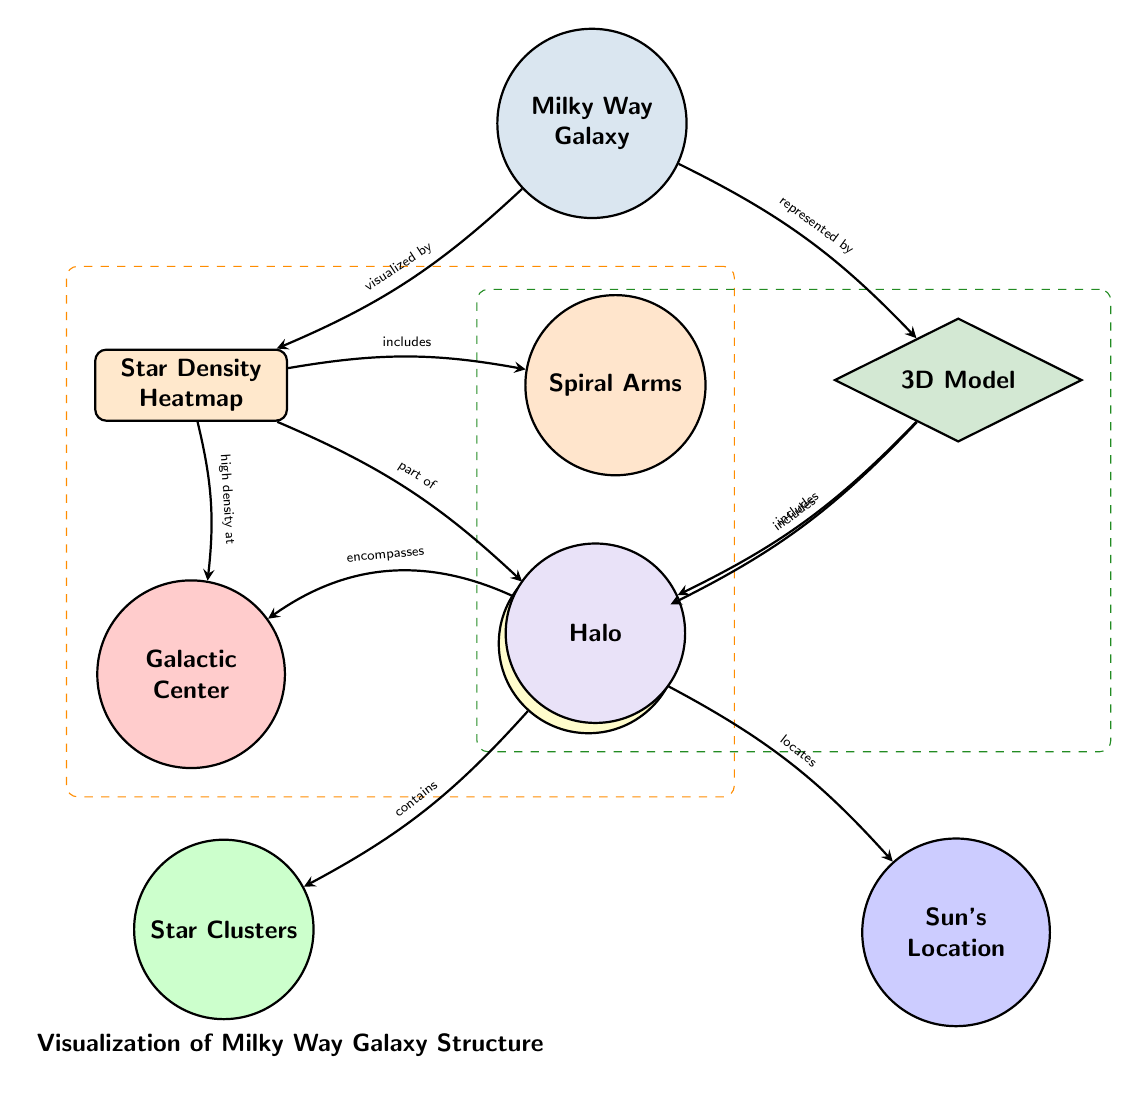What's the main node in this diagram? The main node is labeled "Milky Way Galaxy," which is positioned at the top of the diagram. It serves as the central subject around which other nodes and relationships are organized.
Answer: Milky Way Galaxy How many nodes are in the "Star Density Heatmap" section? In the "Star Density Heatmap" section, there are three nodes: "Galactic Center," "Galactic Disk," and "Spiral Arms." They are directly connected, showing different components related to the star density.
Answer: 3 Which node represents the Sun's location? The node labeled "Sun's Location" is represented as located within the "Galactic Disk" section of the diagram, showing its positional relationship.
Answer: Sun's Location What does the "Halo" encompass according to the diagram? The "Halo" is connected to the "Galactic Center" node via a relationship that indicates it encompasses the galactic center, suggesting that the halo extends around this central point of the Milky Way.
Answer: Galactic Center What connects the "3D Model" node to the "Galactic Disk"? The edge connecting the "3D Model" node to the "Galactic Disk" node is labeled "includes," indicating that the 3D model representation includes features of the galactic disk in its visualization.
Answer: includes How are "Star Clusters" related to the "Galactic Disk"? The "Star Clusters" are included in the "Galactic Disk" node as shown by the edge labeled "contains," which highlights that within the disk structure, star clusters are found.
Answer: contains What color represents the "Halo" node in the diagram? The "Halo" node is represented in a light purple shade, specifically colored as halocolor in the diagram. This color indicates its distinctive role in the galaxy’s structure.
Answer: light purple Are there any edges indicating a relationship from the "Galactic Center" to the "Galactic Disk"? There are no direct edges indicated between the "Galactic Center" and the "Galactic Disk" in the diagram, meaning that while they are components of the Milky Way, they are not directly related under the specific labels shown.
Answer: No Which node is represented by the color "stardensity"? The node specifically represented by the color "stardensity" is the "Star Density Heatmap," which indicates its focus on visualizing star density in the galaxy.
Answer: Star Density Heatmap 